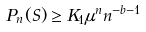Convert formula to latex. <formula><loc_0><loc_0><loc_500><loc_500>P _ { n } ( S ) \geq K _ { 1 } \mu ^ { n } n ^ { - b - 1 }</formula> 